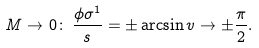Convert formula to latex. <formula><loc_0><loc_0><loc_500><loc_500>M \rightarrow 0 \colon \, \frac { \phi \sigma ^ { 1 } } { s } = \pm \arcsin v \rightarrow \pm \frac { \pi } { 2 } .</formula> 